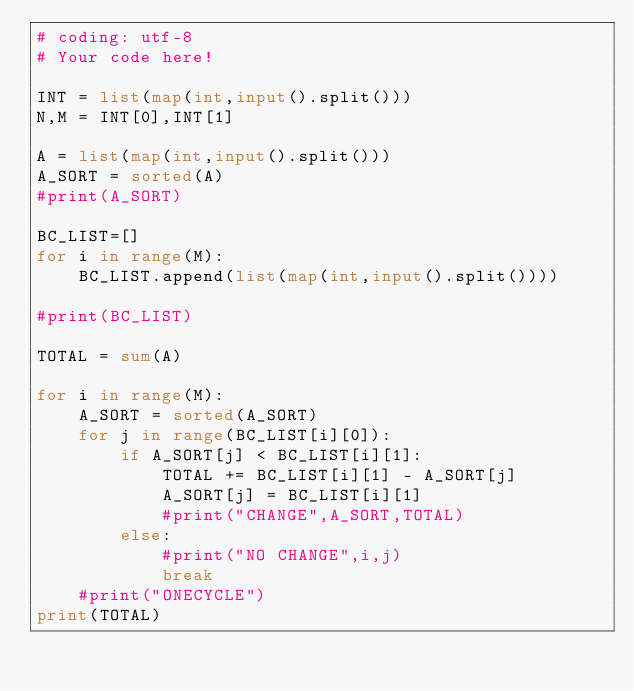Convert code to text. <code><loc_0><loc_0><loc_500><loc_500><_Python_># coding: utf-8
# Your code here!

INT = list(map(int,input().split()))
N,M = INT[0],INT[1]

A = list(map(int,input().split()))
A_SORT = sorted(A)
#print(A_SORT)

BC_LIST=[]
for i in range(M):
    BC_LIST.append(list(map(int,input().split())))

#print(BC_LIST)

TOTAL = sum(A)

for i in range(M):
    A_SORT = sorted(A_SORT)
    for j in range(BC_LIST[i][0]):
        if A_SORT[j] < BC_LIST[i][1]:
            TOTAL += BC_LIST[i][1] - A_SORT[j]
            A_SORT[j] = BC_LIST[i][1]
            #print("CHANGE",A_SORT,TOTAL)
        else:
            #print("NO CHANGE",i,j)
            break
    #print("ONECYCLE")
print(TOTAL)</code> 